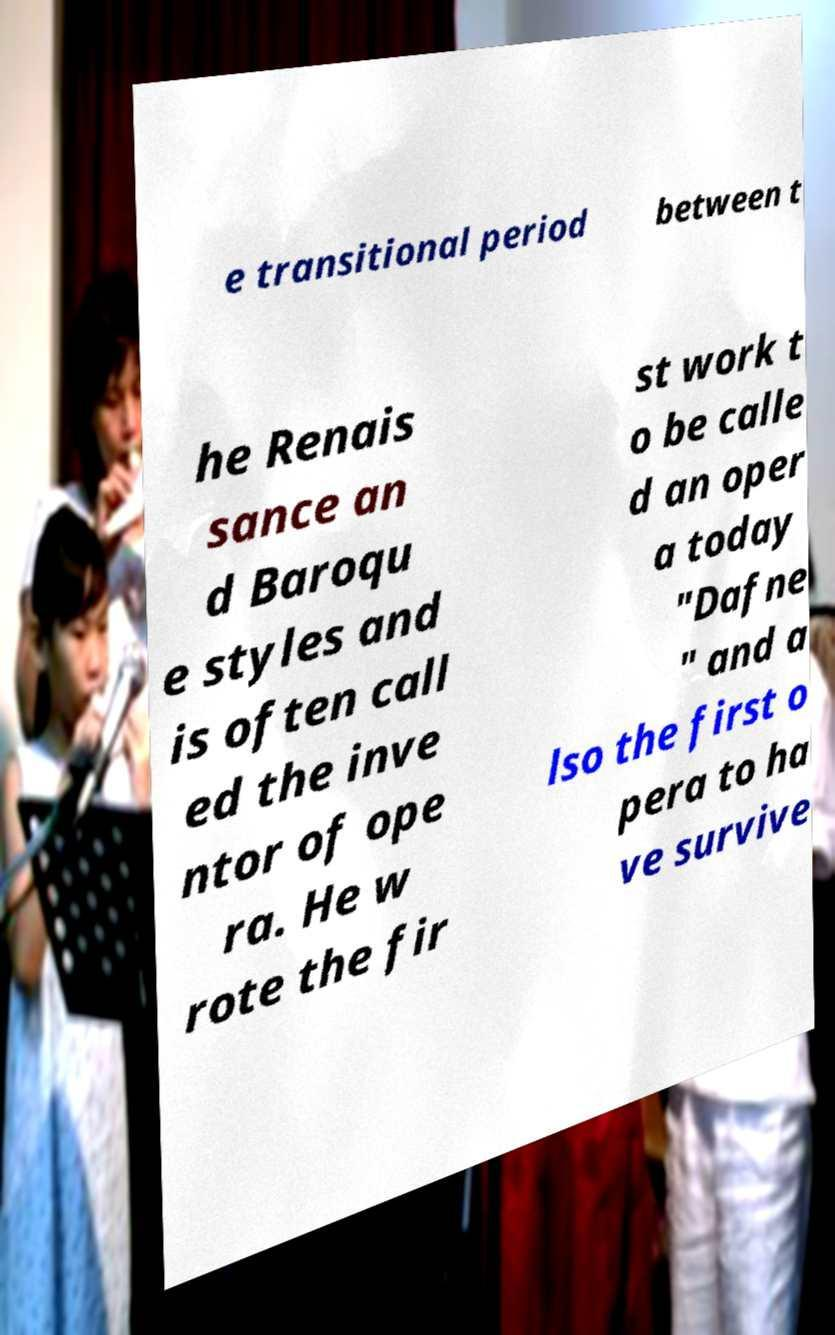Can you read and provide the text displayed in the image?This photo seems to have some interesting text. Can you extract and type it out for me? e transitional period between t he Renais sance an d Baroqu e styles and is often call ed the inve ntor of ope ra. He w rote the fir st work t o be calle d an oper a today "Dafne " and a lso the first o pera to ha ve survive 